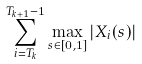Convert formula to latex. <formula><loc_0><loc_0><loc_500><loc_500>\sum _ { i = T _ { k } } ^ { T _ { k + 1 } - 1 } \max _ { s \in [ 0 , 1 ] } | X _ { i } ( s ) |</formula> 